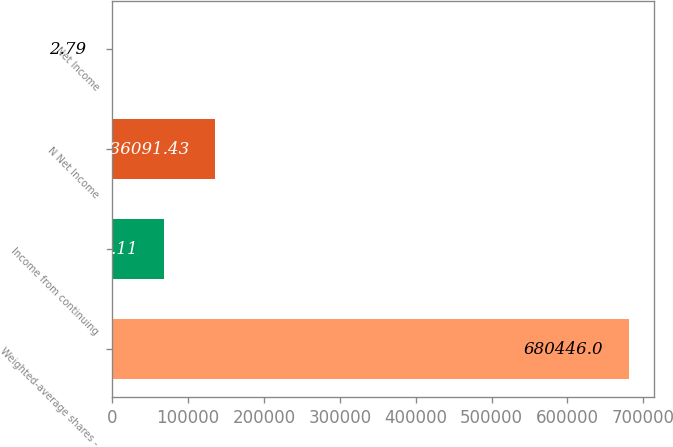<chart> <loc_0><loc_0><loc_500><loc_500><bar_chart><fcel>Weighted-average shares -<fcel>Income from continuing<fcel>N Net Income<fcel>Net Income<nl><fcel>680446<fcel>68047.1<fcel>136091<fcel>2.79<nl></chart> 